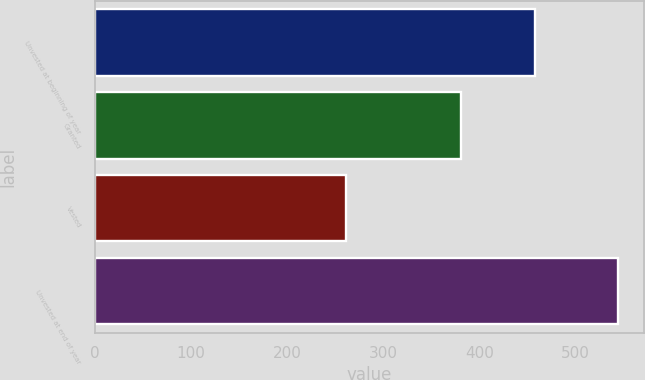<chart> <loc_0><loc_0><loc_500><loc_500><bar_chart><fcel>Unvested at beginning of year<fcel>Granted<fcel>Vested<fcel>Unvested at end of year<nl><fcel>458<fcel>381<fcel>261<fcel>544<nl></chart> 